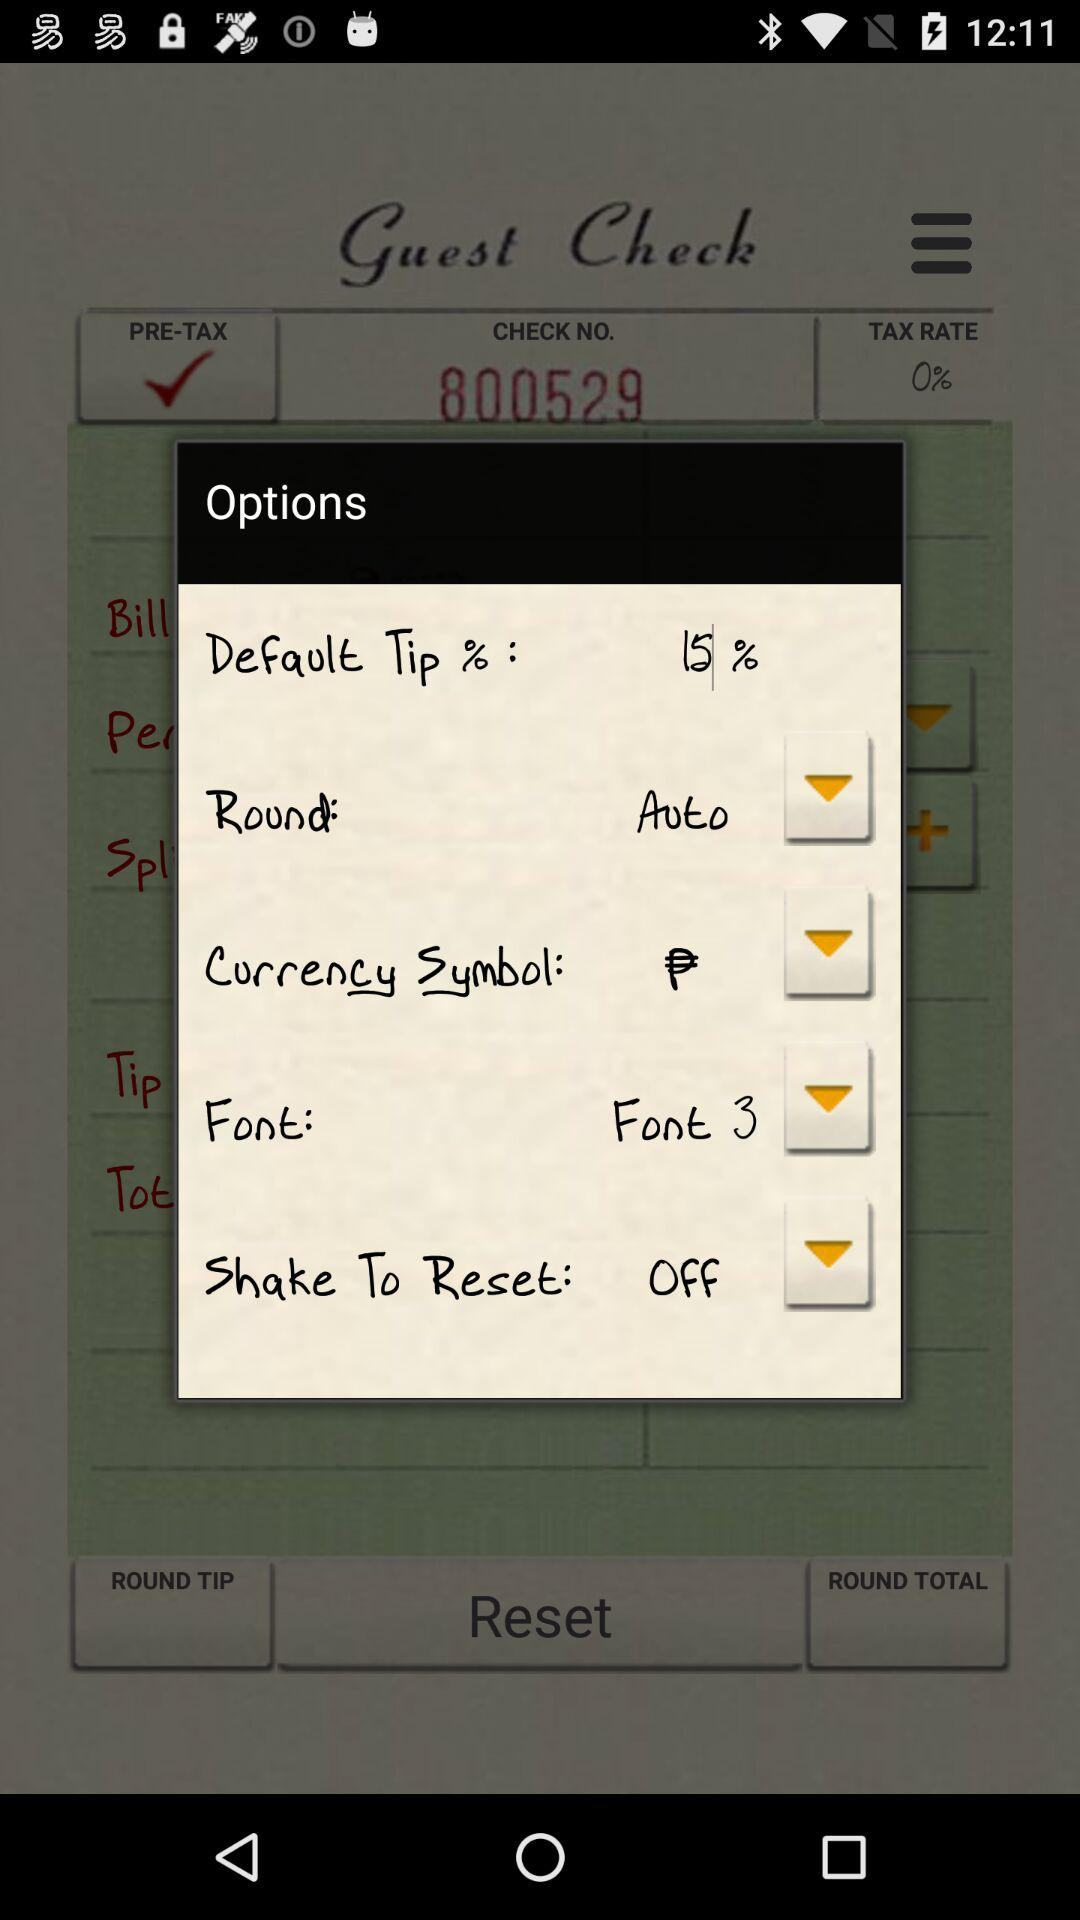What's the setting for "Shake To Reset"? The setting for "Shake To Reset" is "off". 